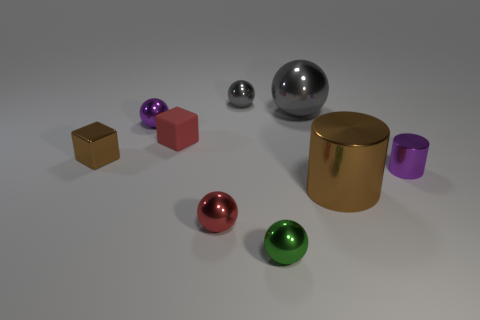How many shiny things are big brown cylinders or small cubes?
Your answer should be very brief. 2. What color is the tiny shiny object that is in front of the small shiny block and behind the big brown metal thing?
Keep it short and to the point. Purple. There is a brown metal thing that is on the right side of the red block; is it the same size as the tiny shiny cube?
Your response must be concise. No. How many objects are small spheres that are behind the metallic cube or small metallic balls?
Provide a short and direct response. 4. Is there a purple ball that has the same size as the red rubber cube?
Your response must be concise. Yes. There is a green ball that is the same size as the purple metallic cylinder; what material is it?
Provide a short and direct response. Metal. What is the shape of the metallic thing that is both in front of the large gray metallic object and behind the metallic block?
Make the answer very short. Sphere. The small block on the left side of the red cube is what color?
Ensure brevity in your answer.  Brown. How big is the sphere that is to the right of the red metallic ball and in front of the tiny cylinder?
Give a very brief answer. Small. Is the material of the red sphere the same as the gray ball on the left side of the small green metal thing?
Offer a terse response. Yes. 